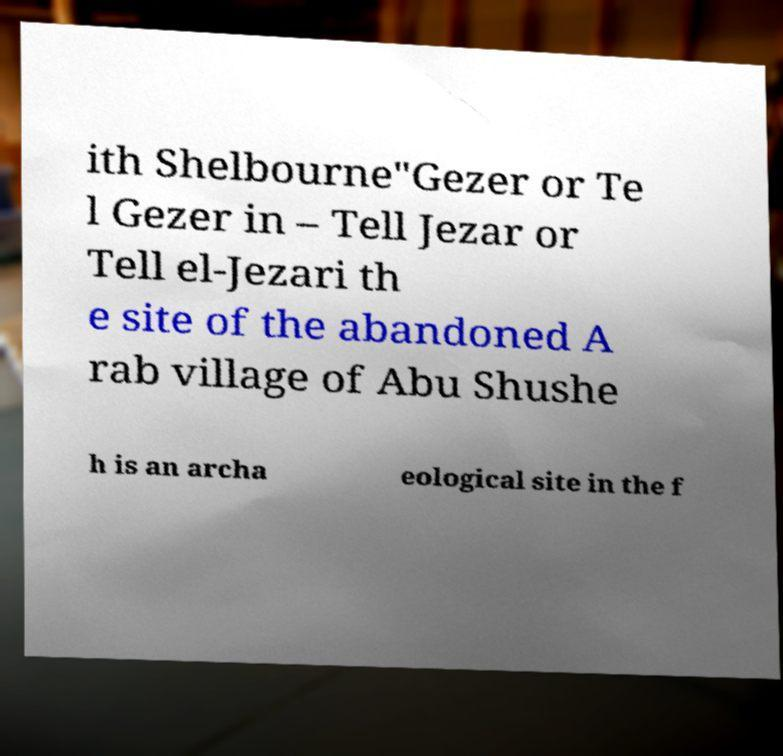I need the written content from this picture converted into text. Can you do that? ith Shelbourne"Gezer or Te l Gezer in – Tell Jezar or Tell el-Jezari th e site of the abandoned A rab village of Abu Shushe h is an archa eological site in the f 